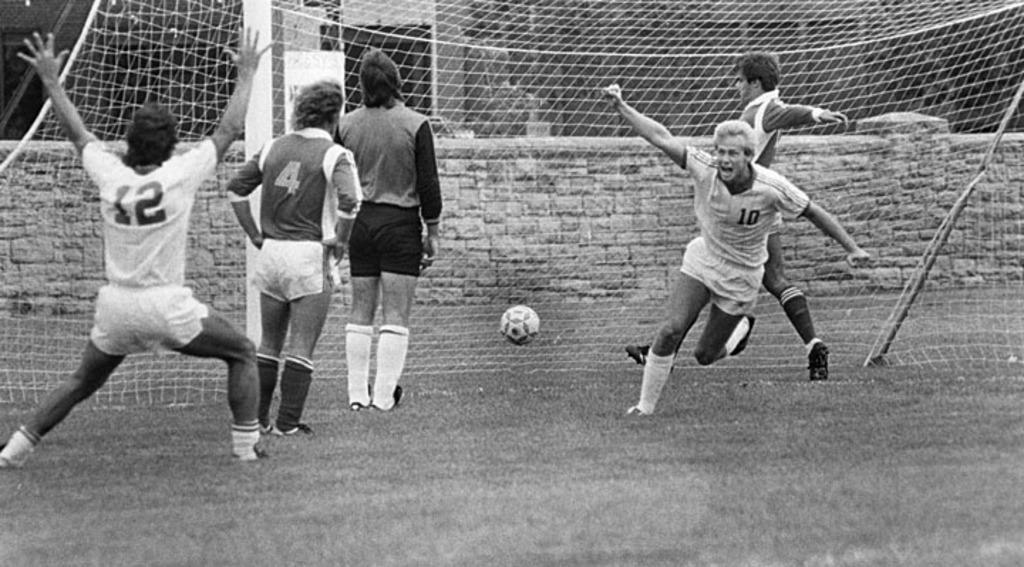What activity are the persons in the image engaged in? The persons in the image are playing football. What is the purpose of the net in the image? The net is likely used to catch or contain the football during the game. What can be seen in the background of the image? There is a wall in the background of the image. What color scheme is used in the image? The image is in black and white color. How many eyes does the football have in the image? The football does not have eyes, as it is an inanimate object. 